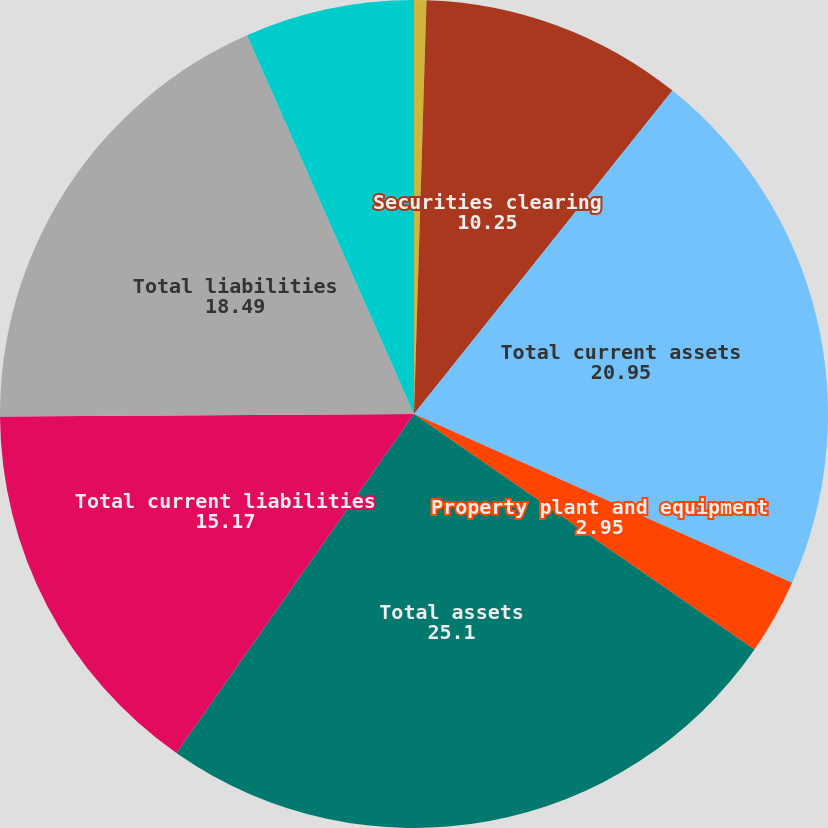Convert chart. <chart><loc_0><loc_0><loc_500><loc_500><pie_chart><fcel>Cash and cash equivalents<fcel>Securities clearing<fcel>Total current assets<fcel>Property plant and equipment<fcel>Total assets<fcel>Total current liabilities<fcel>Total liabilities<fcel>Total stockholders' equity<nl><fcel>0.48%<fcel>10.25%<fcel>20.95%<fcel>2.95%<fcel>25.1%<fcel>15.17%<fcel>18.49%<fcel>6.61%<nl></chart> 